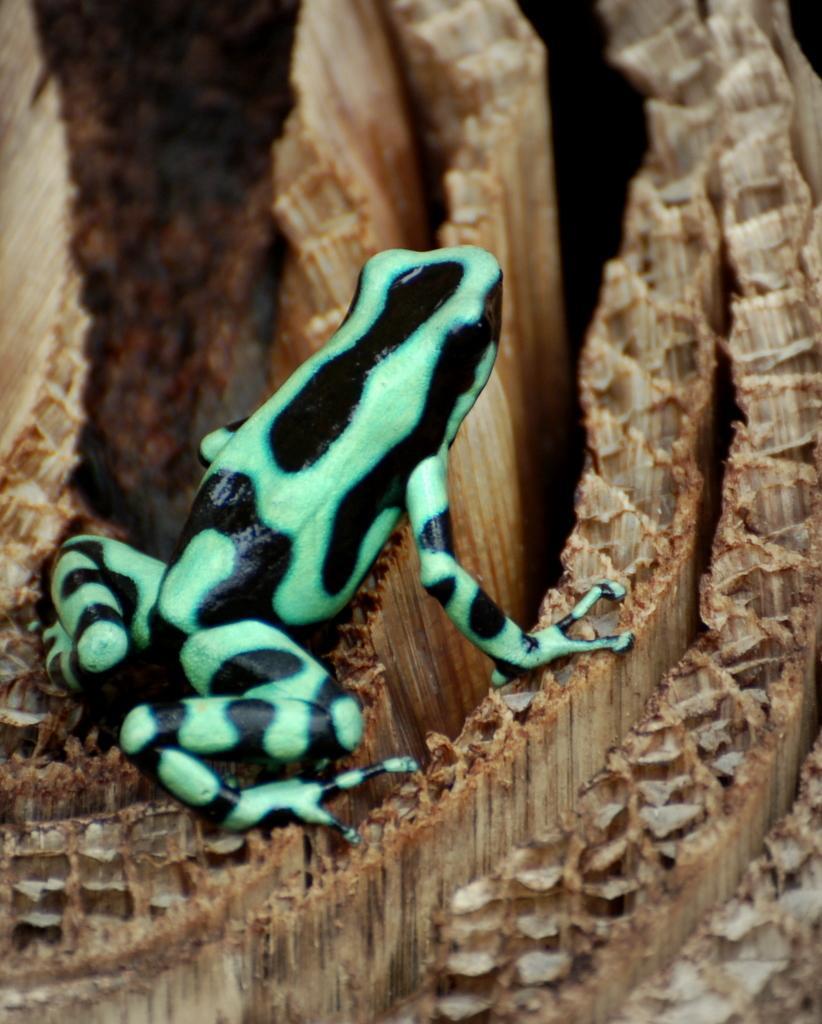Could you give a brief overview of what you see in this image? In this picture we can see a frog on a wooden object. 